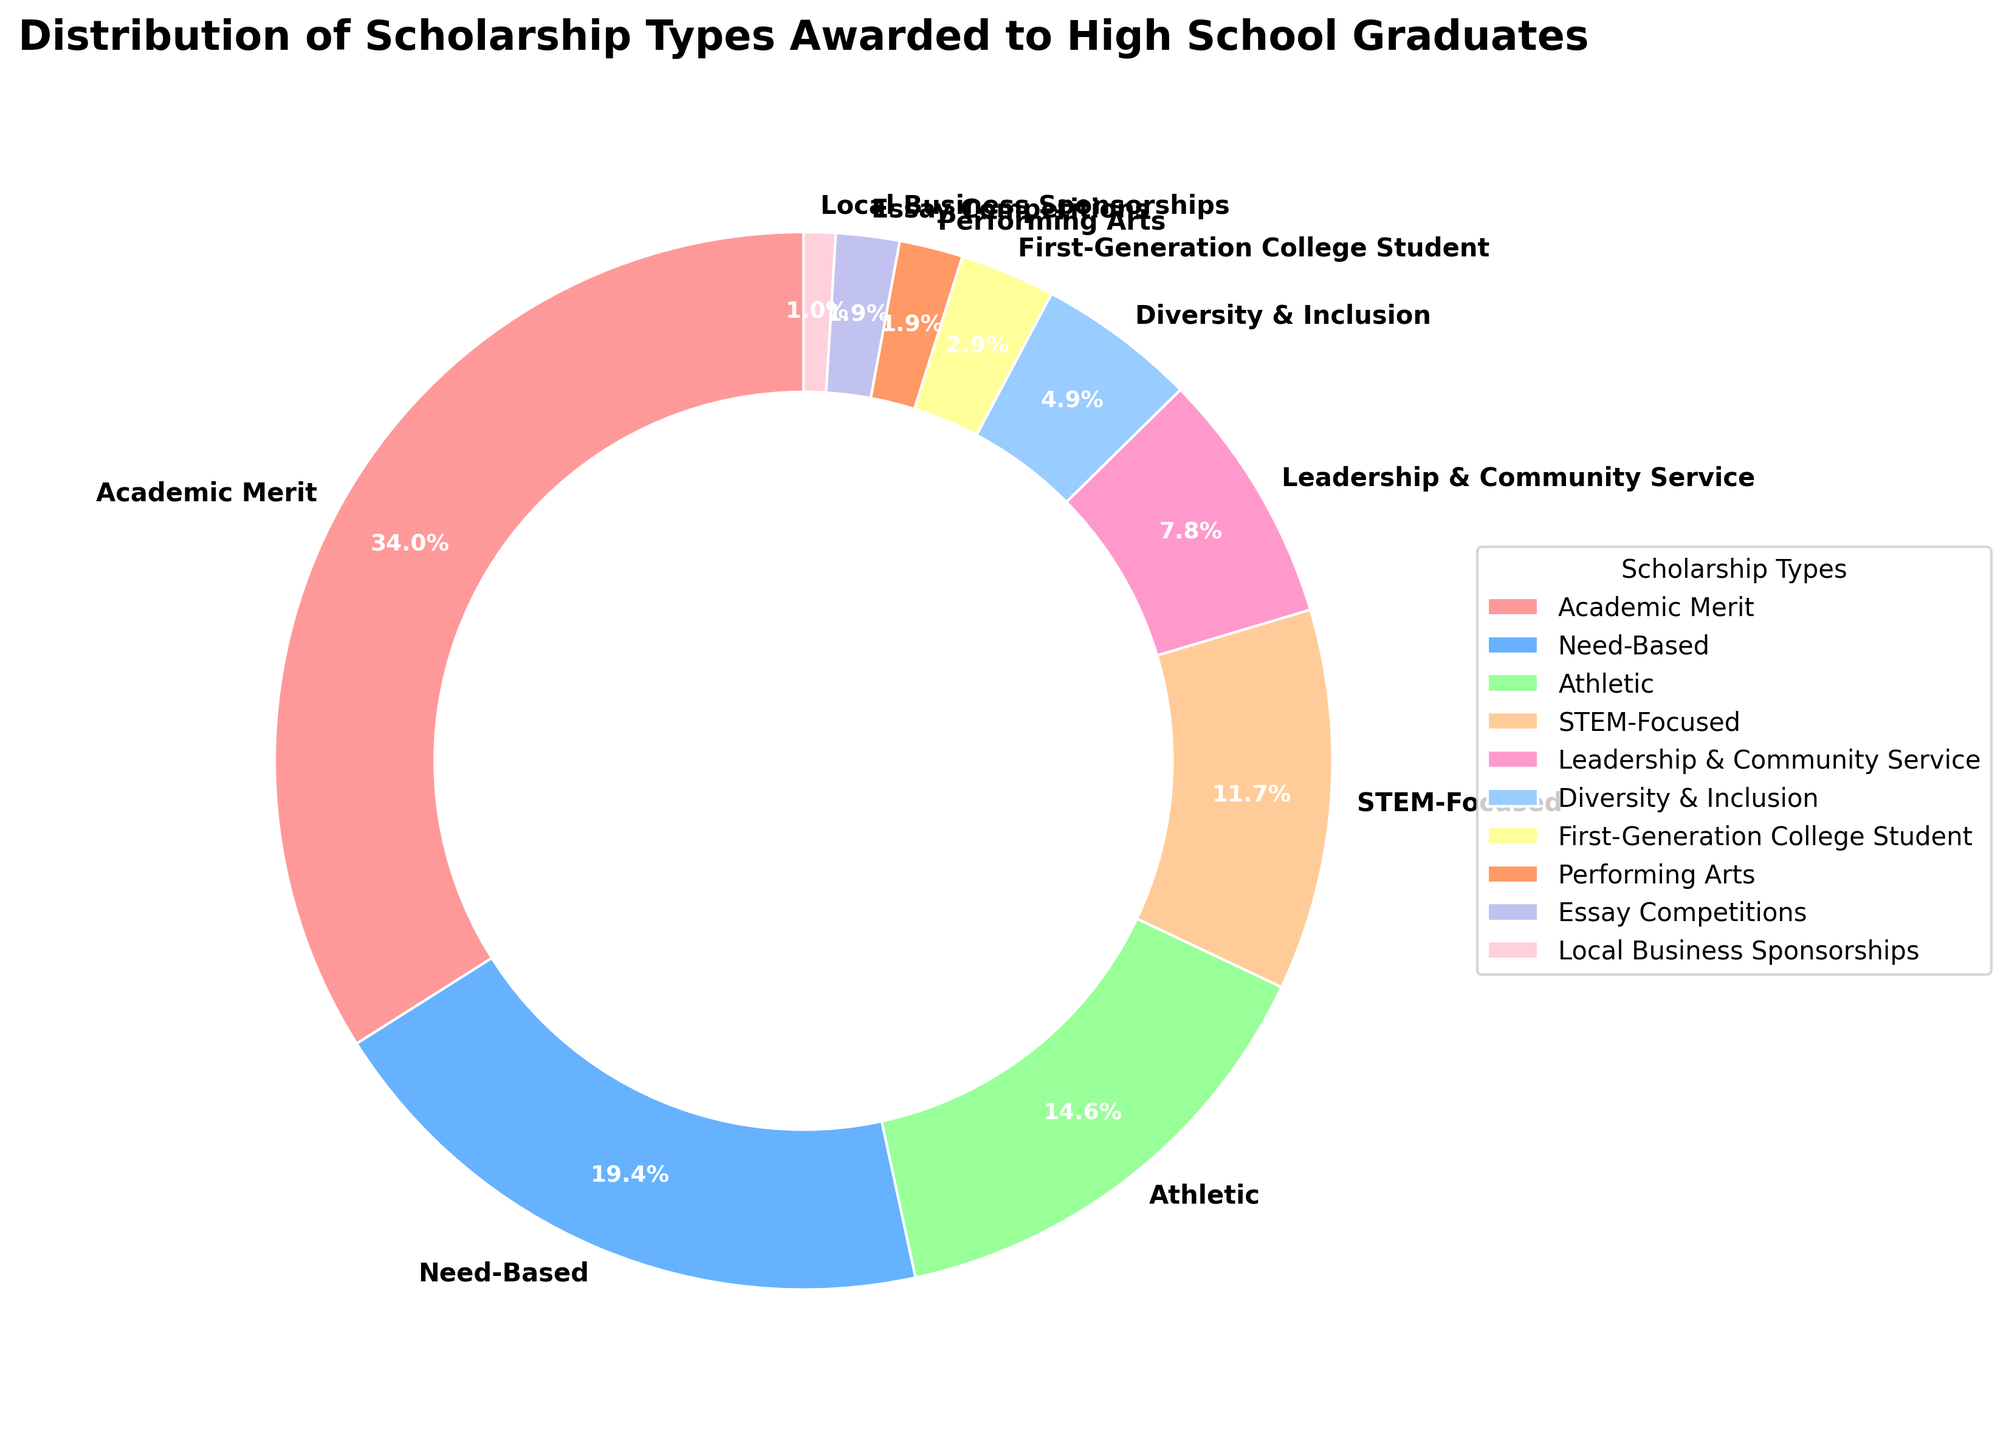Which scholarship type has the highest percentage? From the pie chart, we can see the largest wedge represents 'Academic Merit', and its label shows 35%.
Answer: Academic Merit What is the total percentage of STEM-Focused and Leadership & Community Service scholarships combined? The STEM-Focused scholarships make up 12% and Leadership & Community Service scholarships make up 8%. Adding these two percentages together, we get 12% + 8% = 20%.
Answer: 20% Which scholarship type has a larger percentage: Athletic or Need-Based? The wedges for Athletic and Need-Based scholarships show percentages on the chart. Athletic is 15%, and Need-Based is 20%. Clearly, Need-Based is larger.
Answer: Need-Based What is the difference in percentage between the Academic Merit and Diversity & Inclusion scholarships? The percentage for Academic Merit is 35% and for Diversity & Inclusion is 5%. The difference is 35% - 5% = 30%.
Answer: 30% How many types of scholarships have a percentage less than or equal to 5%? From the pie chart, we see that Diversity & Inclusion (5%), First-Generation College Student (3%), Performing Arts (2%), Essay Competitions (2%), and Local Business Sponsorships (1%) fall into this category. There are 5 types in total.
Answer: 5 Which color represents the Leadership & Community Service scholarships in the pie chart? According to the chart, the wedge for Leadership & Community Service scholarships is a light pinkish color.
Answer: light pinkish What is the average percentage of Performing Arts, Essay Competitions, and Local Business Sponsorships scholarships? Performing Arts is 2%, Essay Competitions is 2%, and Local Business Sponsorships is 1%. The total is 2% + 2% + 1% = 5%. The average is 5% / 3 = 1.67%
Answer: 1.67% Are there more need-based scholarships or athletic scholarships, and by how much? Need-Based at 20% is greater than Athletic at 15%. The difference is 20% - 15% = 5%.
Answer: Need-Based by 5% 